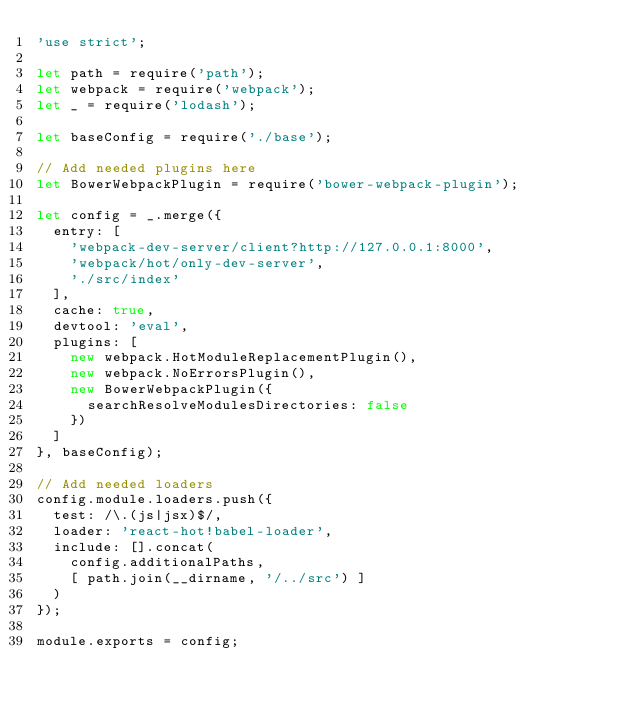Convert code to text. <code><loc_0><loc_0><loc_500><loc_500><_JavaScript_>'use strict';

let path = require('path');
let webpack = require('webpack');
let _ = require('lodash');

let baseConfig = require('./base');

// Add needed plugins here
let BowerWebpackPlugin = require('bower-webpack-plugin');

let config = _.merge({
  entry: [
    'webpack-dev-server/client?http://127.0.0.1:8000',
    'webpack/hot/only-dev-server',
    './src/index'
  ],
  cache: true,
  devtool: 'eval',
  plugins: [
    new webpack.HotModuleReplacementPlugin(),
    new webpack.NoErrorsPlugin(),
    new BowerWebpackPlugin({
      searchResolveModulesDirectories: false
    })
  ]
}, baseConfig);

// Add needed loaders
config.module.loaders.push({
  test: /\.(js|jsx)$/,
  loader: 'react-hot!babel-loader',
  include: [].concat(
    config.additionalPaths,
    [ path.join(__dirname, '/../src') ]
  )
});

module.exports = config;
</code> 